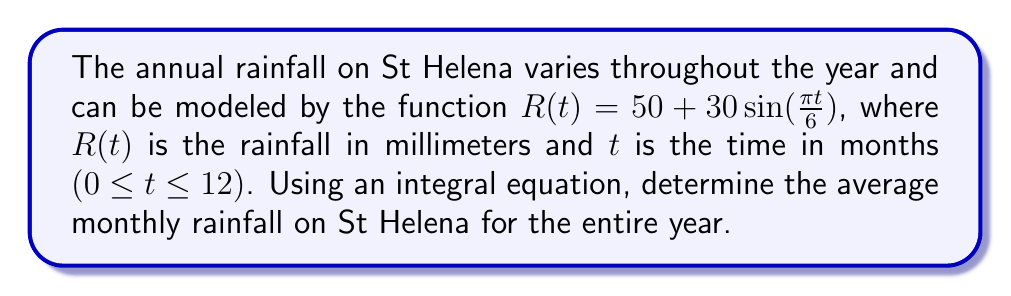Give your solution to this math problem. To find the average monthly rainfall, we need to:

1. Calculate the total rainfall for the year using an integral.
2. Divide the total rainfall by the number of months (12).

Step 1: Set up the integral for total rainfall
The total rainfall is the area under the curve $R(t)$ from $t=0$ to $t=12$:

$$\text{Total Rainfall} = \int_0^{12} R(t) dt = \int_0^{12} (50 + 30\sin(\frac{\pi t}{6})) dt$$

Step 2: Solve the integral
$$\begin{align*}
\int_0^{12} (50 + 30\sin(\frac{\pi t}{6})) dt &= 50t - \frac{180}{\pi}\cos(\frac{\pi t}{6}) \bigg|_0^{12} \\
&= (600 - \frac{180}{\pi}\cos(2\pi)) - (0 - \frac{180}{\pi}\cos(0)) \\
&= 600 - \frac{180}{\pi}\cos(2\pi) + \frac{180}{\pi} \\
&= 600 + \frac{180}{\pi}(1 - \cos(2\pi)) \\
&= 600 \text{ (since } \cos(2\pi) = 1)
\end{align*}$$

Step 3: Calculate the average monthly rainfall
Average Monthly Rainfall = Total Rainfall ÷ Number of Months
$$\text{Average Monthly Rainfall} = \frac{600}{12} = 50 \text{ mm}$$
Answer: 50 mm 